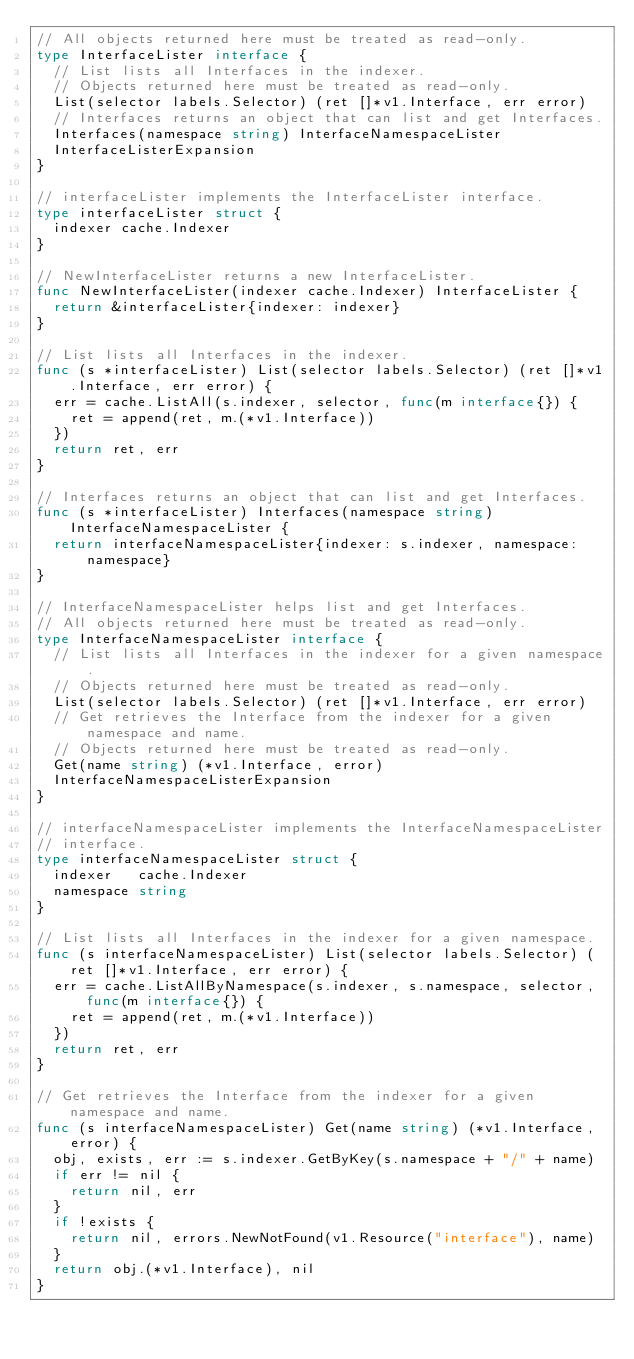Convert code to text. <code><loc_0><loc_0><loc_500><loc_500><_Go_>// All objects returned here must be treated as read-only.
type InterfaceLister interface {
	// List lists all Interfaces in the indexer.
	// Objects returned here must be treated as read-only.
	List(selector labels.Selector) (ret []*v1.Interface, err error)
	// Interfaces returns an object that can list and get Interfaces.
	Interfaces(namespace string) InterfaceNamespaceLister
	InterfaceListerExpansion
}

// interfaceLister implements the InterfaceLister interface.
type interfaceLister struct {
	indexer cache.Indexer
}

// NewInterfaceLister returns a new InterfaceLister.
func NewInterfaceLister(indexer cache.Indexer) InterfaceLister {
	return &interfaceLister{indexer: indexer}
}

// List lists all Interfaces in the indexer.
func (s *interfaceLister) List(selector labels.Selector) (ret []*v1.Interface, err error) {
	err = cache.ListAll(s.indexer, selector, func(m interface{}) {
		ret = append(ret, m.(*v1.Interface))
	})
	return ret, err
}

// Interfaces returns an object that can list and get Interfaces.
func (s *interfaceLister) Interfaces(namespace string) InterfaceNamespaceLister {
	return interfaceNamespaceLister{indexer: s.indexer, namespace: namespace}
}

// InterfaceNamespaceLister helps list and get Interfaces.
// All objects returned here must be treated as read-only.
type InterfaceNamespaceLister interface {
	// List lists all Interfaces in the indexer for a given namespace.
	// Objects returned here must be treated as read-only.
	List(selector labels.Selector) (ret []*v1.Interface, err error)
	// Get retrieves the Interface from the indexer for a given namespace and name.
	// Objects returned here must be treated as read-only.
	Get(name string) (*v1.Interface, error)
	InterfaceNamespaceListerExpansion
}

// interfaceNamespaceLister implements the InterfaceNamespaceLister
// interface.
type interfaceNamespaceLister struct {
	indexer   cache.Indexer
	namespace string
}

// List lists all Interfaces in the indexer for a given namespace.
func (s interfaceNamespaceLister) List(selector labels.Selector) (ret []*v1.Interface, err error) {
	err = cache.ListAllByNamespace(s.indexer, s.namespace, selector, func(m interface{}) {
		ret = append(ret, m.(*v1.Interface))
	})
	return ret, err
}

// Get retrieves the Interface from the indexer for a given namespace and name.
func (s interfaceNamespaceLister) Get(name string) (*v1.Interface, error) {
	obj, exists, err := s.indexer.GetByKey(s.namespace + "/" + name)
	if err != nil {
		return nil, err
	}
	if !exists {
		return nil, errors.NewNotFound(v1.Resource("interface"), name)
	}
	return obj.(*v1.Interface), nil
}
</code> 